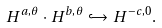<formula> <loc_0><loc_0><loc_500><loc_500>H ^ { a , \theta } \cdot H ^ { b , \theta } \hookrightarrow H ^ { - c , 0 } .</formula> 